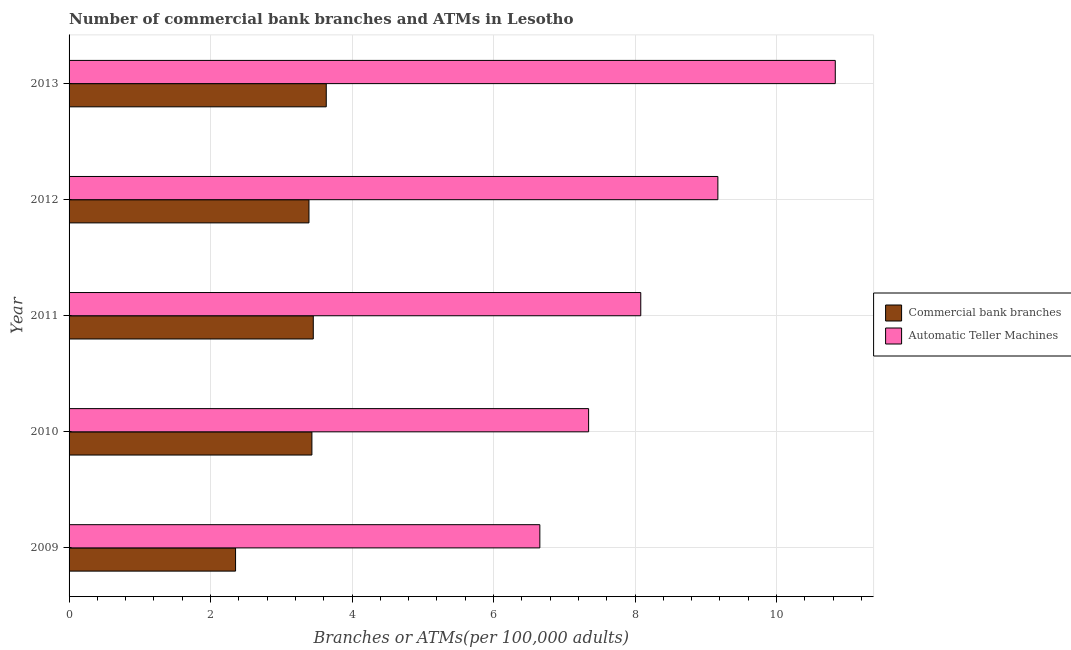How many different coloured bars are there?
Your response must be concise. 2. Are the number of bars on each tick of the Y-axis equal?
Provide a short and direct response. Yes. What is the label of the 4th group of bars from the top?
Make the answer very short. 2010. In how many cases, is the number of bars for a given year not equal to the number of legend labels?
Give a very brief answer. 0. What is the number of commercal bank branches in 2009?
Offer a very short reply. 2.35. Across all years, what is the maximum number of atms?
Ensure brevity in your answer.  10.83. Across all years, what is the minimum number of atms?
Provide a short and direct response. 6.65. In which year was the number of commercal bank branches minimum?
Your response must be concise. 2009. What is the total number of commercal bank branches in the graph?
Keep it short and to the point. 16.26. What is the difference between the number of commercal bank branches in 2009 and that in 2011?
Your answer should be compact. -1.1. What is the difference between the number of commercal bank branches in 2009 and the number of atms in 2013?
Ensure brevity in your answer.  -8.48. What is the average number of commercal bank branches per year?
Offer a terse response. 3.25. In the year 2013, what is the difference between the number of atms and number of commercal bank branches?
Provide a short and direct response. 7.2. In how many years, is the number of atms greater than 2 ?
Keep it short and to the point. 5. What is the ratio of the number of atms in 2009 to that in 2013?
Make the answer very short. 0.61. What is the difference between the highest and the second highest number of commercal bank branches?
Your answer should be compact. 0.18. What is the difference between the highest and the lowest number of atms?
Provide a short and direct response. 4.18. In how many years, is the number of atms greater than the average number of atms taken over all years?
Your answer should be compact. 2. Is the sum of the number of atms in 2010 and 2013 greater than the maximum number of commercal bank branches across all years?
Your response must be concise. Yes. What does the 2nd bar from the top in 2010 represents?
Your answer should be compact. Commercial bank branches. What does the 1st bar from the bottom in 2010 represents?
Provide a short and direct response. Commercial bank branches. Are the values on the major ticks of X-axis written in scientific E-notation?
Offer a very short reply. No. Does the graph contain any zero values?
Your response must be concise. No. Does the graph contain grids?
Provide a succinct answer. Yes. How many legend labels are there?
Make the answer very short. 2. What is the title of the graph?
Keep it short and to the point. Number of commercial bank branches and ATMs in Lesotho. Does "current US$" appear as one of the legend labels in the graph?
Your response must be concise. No. What is the label or title of the X-axis?
Your answer should be compact. Branches or ATMs(per 100,0 adults). What is the Branches or ATMs(per 100,000 adults) of Commercial bank branches in 2009?
Your answer should be compact. 2.35. What is the Branches or ATMs(per 100,000 adults) of Automatic Teller Machines in 2009?
Provide a succinct answer. 6.65. What is the Branches or ATMs(per 100,000 adults) in Commercial bank branches in 2010?
Keep it short and to the point. 3.43. What is the Branches or ATMs(per 100,000 adults) in Automatic Teller Machines in 2010?
Your response must be concise. 7.34. What is the Branches or ATMs(per 100,000 adults) of Commercial bank branches in 2011?
Your answer should be compact. 3.45. What is the Branches or ATMs(per 100,000 adults) in Automatic Teller Machines in 2011?
Offer a very short reply. 8.08. What is the Branches or ATMs(per 100,000 adults) in Commercial bank branches in 2012?
Ensure brevity in your answer.  3.39. What is the Branches or ATMs(per 100,000 adults) in Automatic Teller Machines in 2012?
Your answer should be very brief. 9.17. What is the Branches or ATMs(per 100,000 adults) of Commercial bank branches in 2013?
Offer a terse response. 3.64. What is the Branches or ATMs(per 100,000 adults) in Automatic Teller Machines in 2013?
Your response must be concise. 10.83. Across all years, what is the maximum Branches or ATMs(per 100,000 adults) in Commercial bank branches?
Provide a succinct answer. 3.64. Across all years, what is the maximum Branches or ATMs(per 100,000 adults) of Automatic Teller Machines?
Provide a succinct answer. 10.83. Across all years, what is the minimum Branches or ATMs(per 100,000 adults) in Commercial bank branches?
Keep it short and to the point. 2.35. Across all years, what is the minimum Branches or ATMs(per 100,000 adults) in Automatic Teller Machines?
Your answer should be compact. 6.65. What is the total Branches or ATMs(per 100,000 adults) of Commercial bank branches in the graph?
Your answer should be compact. 16.26. What is the total Branches or ATMs(per 100,000 adults) in Automatic Teller Machines in the graph?
Keep it short and to the point. 42.08. What is the difference between the Branches or ATMs(per 100,000 adults) in Commercial bank branches in 2009 and that in 2010?
Your response must be concise. -1.08. What is the difference between the Branches or ATMs(per 100,000 adults) in Automatic Teller Machines in 2009 and that in 2010?
Provide a succinct answer. -0.69. What is the difference between the Branches or ATMs(per 100,000 adults) in Commercial bank branches in 2009 and that in 2011?
Your answer should be compact. -1.1. What is the difference between the Branches or ATMs(per 100,000 adults) in Automatic Teller Machines in 2009 and that in 2011?
Provide a short and direct response. -1.43. What is the difference between the Branches or ATMs(per 100,000 adults) in Commercial bank branches in 2009 and that in 2012?
Your answer should be compact. -1.04. What is the difference between the Branches or ATMs(per 100,000 adults) of Automatic Teller Machines in 2009 and that in 2012?
Your answer should be compact. -2.52. What is the difference between the Branches or ATMs(per 100,000 adults) in Commercial bank branches in 2009 and that in 2013?
Provide a short and direct response. -1.28. What is the difference between the Branches or ATMs(per 100,000 adults) of Automatic Teller Machines in 2009 and that in 2013?
Keep it short and to the point. -4.18. What is the difference between the Branches or ATMs(per 100,000 adults) in Commercial bank branches in 2010 and that in 2011?
Offer a very short reply. -0.02. What is the difference between the Branches or ATMs(per 100,000 adults) in Automatic Teller Machines in 2010 and that in 2011?
Make the answer very short. -0.74. What is the difference between the Branches or ATMs(per 100,000 adults) in Commercial bank branches in 2010 and that in 2012?
Provide a succinct answer. 0.04. What is the difference between the Branches or ATMs(per 100,000 adults) in Automatic Teller Machines in 2010 and that in 2012?
Your answer should be compact. -1.83. What is the difference between the Branches or ATMs(per 100,000 adults) in Commercial bank branches in 2010 and that in 2013?
Offer a very short reply. -0.2. What is the difference between the Branches or ATMs(per 100,000 adults) of Automatic Teller Machines in 2010 and that in 2013?
Offer a terse response. -3.49. What is the difference between the Branches or ATMs(per 100,000 adults) of Commercial bank branches in 2011 and that in 2012?
Make the answer very short. 0.06. What is the difference between the Branches or ATMs(per 100,000 adults) of Automatic Teller Machines in 2011 and that in 2012?
Your answer should be compact. -1.09. What is the difference between the Branches or ATMs(per 100,000 adults) in Commercial bank branches in 2011 and that in 2013?
Your answer should be very brief. -0.18. What is the difference between the Branches or ATMs(per 100,000 adults) of Automatic Teller Machines in 2011 and that in 2013?
Your answer should be very brief. -2.75. What is the difference between the Branches or ATMs(per 100,000 adults) in Commercial bank branches in 2012 and that in 2013?
Ensure brevity in your answer.  -0.24. What is the difference between the Branches or ATMs(per 100,000 adults) of Automatic Teller Machines in 2012 and that in 2013?
Offer a very short reply. -1.66. What is the difference between the Branches or ATMs(per 100,000 adults) of Commercial bank branches in 2009 and the Branches or ATMs(per 100,000 adults) of Automatic Teller Machines in 2010?
Provide a succinct answer. -4.99. What is the difference between the Branches or ATMs(per 100,000 adults) of Commercial bank branches in 2009 and the Branches or ATMs(per 100,000 adults) of Automatic Teller Machines in 2011?
Keep it short and to the point. -5.73. What is the difference between the Branches or ATMs(per 100,000 adults) in Commercial bank branches in 2009 and the Branches or ATMs(per 100,000 adults) in Automatic Teller Machines in 2012?
Ensure brevity in your answer.  -6.82. What is the difference between the Branches or ATMs(per 100,000 adults) in Commercial bank branches in 2009 and the Branches or ATMs(per 100,000 adults) in Automatic Teller Machines in 2013?
Make the answer very short. -8.48. What is the difference between the Branches or ATMs(per 100,000 adults) in Commercial bank branches in 2010 and the Branches or ATMs(per 100,000 adults) in Automatic Teller Machines in 2011?
Your answer should be very brief. -4.65. What is the difference between the Branches or ATMs(per 100,000 adults) of Commercial bank branches in 2010 and the Branches or ATMs(per 100,000 adults) of Automatic Teller Machines in 2012?
Provide a short and direct response. -5.74. What is the difference between the Branches or ATMs(per 100,000 adults) of Commercial bank branches in 2010 and the Branches or ATMs(per 100,000 adults) of Automatic Teller Machines in 2013?
Give a very brief answer. -7.4. What is the difference between the Branches or ATMs(per 100,000 adults) of Commercial bank branches in 2011 and the Branches or ATMs(per 100,000 adults) of Automatic Teller Machines in 2012?
Your answer should be very brief. -5.72. What is the difference between the Branches or ATMs(per 100,000 adults) of Commercial bank branches in 2011 and the Branches or ATMs(per 100,000 adults) of Automatic Teller Machines in 2013?
Your answer should be compact. -7.38. What is the difference between the Branches or ATMs(per 100,000 adults) of Commercial bank branches in 2012 and the Branches or ATMs(per 100,000 adults) of Automatic Teller Machines in 2013?
Your answer should be compact. -7.44. What is the average Branches or ATMs(per 100,000 adults) in Commercial bank branches per year?
Give a very brief answer. 3.25. What is the average Branches or ATMs(per 100,000 adults) of Automatic Teller Machines per year?
Your answer should be compact. 8.42. In the year 2009, what is the difference between the Branches or ATMs(per 100,000 adults) in Commercial bank branches and Branches or ATMs(per 100,000 adults) in Automatic Teller Machines?
Your answer should be compact. -4.3. In the year 2010, what is the difference between the Branches or ATMs(per 100,000 adults) of Commercial bank branches and Branches or ATMs(per 100,000 adults) of Automatic Teller Machines?
Keep it short and to the point. -3.91. In the year 2011, what is the difference between the Branches or ATMs(per 100,000 adults) in Commercial bank branches and Branches or ATMs(per 100,000 adults) in Automatic Teller Machines?
Offer a very short reply. -4.63. In the year 2012, what is the difference between the Branches or ATMs(per 100,000 adults) in Commercial bank branches and Branches or ATMs(per 100,000 adults) in Automatic Teller Machines?
Keep it short and to the point. -5.78. In the year 2013, what is the difference between the Branches or ATMs(per 100,000 adults) in Commercial bank branches and Branches or ATMs(per 100,000 adults) in Automatic Teller Machines?
Ensure brevity in your answer.  -7.2. What is the ratio of the Branches or ATMs(per 100,000 adults) of Commercial bank branches in 2009 to that in 2010?
Your response must be concise. 0.69. What is the ratio of the Branches or ATMs(per 100,000 adults) in Automatic Teller Machines in 2009 to that in 2010?
Keep it short and to the point. 0.91. What is the ratio of the Branches or ATMs(per 100,000 adults) in Commercial bank branches in 2009 to that in 2011?
Your answer should be very brief. 0.68. What is the ratio of the Branches or ATMs(per 100,000 adults) of Automatic Teller Machines in 2009 to that in 2011?
Keep it short and to the point. 0.82. What is the ratio of the Branches or ATMs(per 100,000 adults) of Commercial bank branches in 2009 to that in 2012?
Offer a very short reply. 0.69. What is the ratio of the Branches or ATMs(per 100,000 adults) of Automatic Teller Machines in 2009 to that in 2012?
Your answer should be compact. 0.73. What is the ratio of the Branches or ATMs(per 100,000 adults) in Commercial bank branches in 2009 to that in 2013?
Offer a very short reply. 0.65. What is the ratio of the Branches or ATMs(per 100,000 adults) in Automatic Teller Machines in 2009 to that in 2013?
Your answer should be compact. 0.61. What is the ratio of the Branches or ATMs(per 100,000 adults) of Automatic Teller Machines in 2010 to that in 2011?
Your answer should be very brief. 0.91. What is the ratio of the Branches or ATMs(per 100,000 adults) of Commercial bank branches in 2010 to that in 2012?
Your response must be concise. 1.01. What is the ratio of the Branches or ATMs(per 100,000 adults) in Automatic Teller Machines in 2010 to that in 2012?
Ensure brevity in your answer.  0.8. What is the ratio of the Branches or ATMs(per 100,000 adults) of Commercial bank branches in 2010 to that in 2013?
Keep it short and to the point. 0.94. What is the ratio of the Branches or ATMs(per 100,000 adults) in Automatic Teller Machines in 2010 to that in 2013?
Make the answer very short. 0.68. What is the ratio of the Branches or ATMs(per 100,000 adults) of Automatic Teller Machines in 2011 to that in 2012?
Offer a very short reply. 0.88. What is the ratio of the Branches or ATMs(per 100,000 adults) of Commercial bank branches in 2011 to that in 2013?
Your answer should be compact. 0.95. What is the ratio of the Branches or ATMs(per 100,000 adults) in Automatic Teller Machines in 2011 to that in 2013?
Your response must be concise. 0.75. What is the ratio of the Branches or ATMs(per 100,000 adults) of Commercial bank branches in 2012 to that in 2013?
Give a very brief answer. 0.93. What is the ratio of the Branches or ATMs(per 100,000 adults) in Automatic Teller Machines in 2012 to that in 2013?
Keep it short and to the point. 0.85. What is the difference between the highest and the second highest Branches or ATMs(per 100,000 adults) in Commercial bank branches?
Make the answer very short. 0.18. What is the difference between the highest and the second highest Branches or ATMs(per 100,000 adults) in Automatic Teller Machines?
Provide a short and direct response. 1.66. What is the difference between the highest and the lowest Branches or ATMs(per 100,000 adults) in Commercial bank branches?
Your answer should be compact. 1.28. What is the difference between the highest and the lowest Branches or ATMs(per 100,000 adults) in Automatic Teller Machines?
Give a very brief answer. 4.18. 